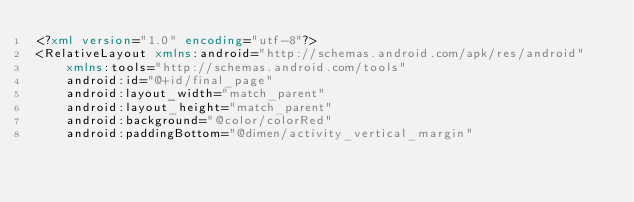<code> <loc_0><loc_0><loc_500><loc_500><_XML_><?xml version="1.0" encoding="utf-8"?>
<RelativeLayout xmlns:android="http://schemas.android.com/apk/res/android"
    xmlns:tools="http://schemas.android.com/tools"
    android:id="@+id/final_page"
    android:layout_width="match_parent"
    android:layout_height="match_parent"
    android:background="@color/colorRed"
    android:paddingBottom="@dimen/activity_vertical_margin"</code> 